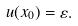Convert formula to latex. <formula><loc_0><loc_0><loc_500><loc_500>u ( x _ { 0 } ) = \varepsilon .</formula> 